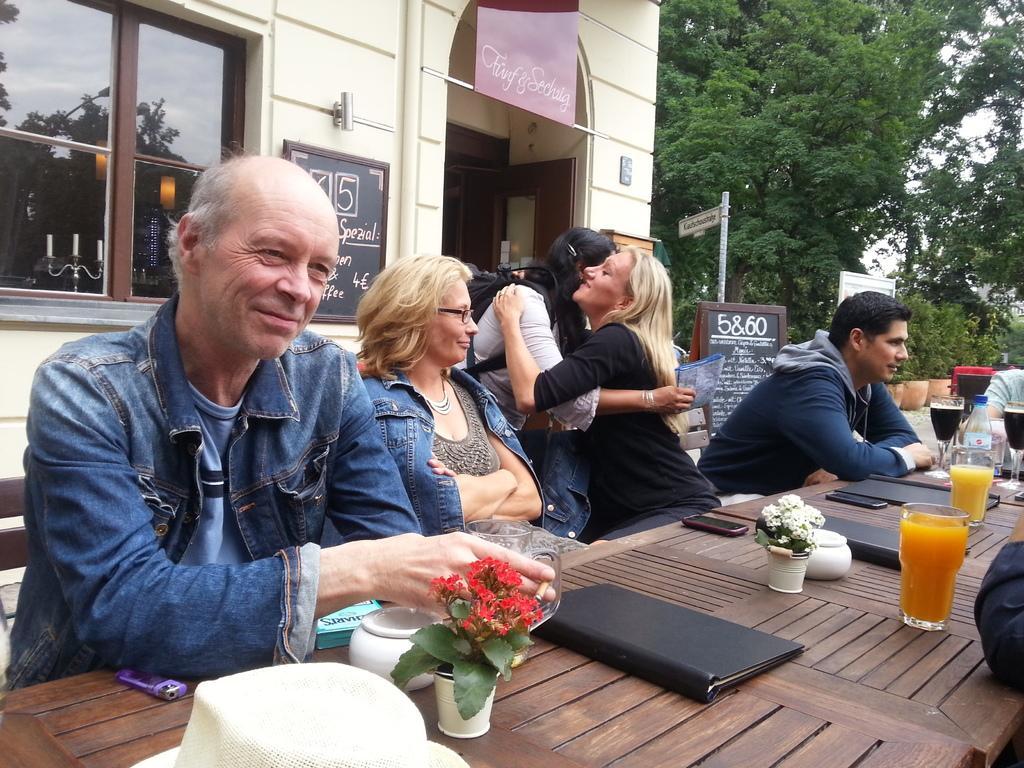Could you give a brief overview of what you see in this image? In this image I can see there are group of people among them, few are sitting on a chair in front of a table and few are hugging each other. I can see on table there are few glasses, flower and other objects on it. I can also say there is a tree and house. 